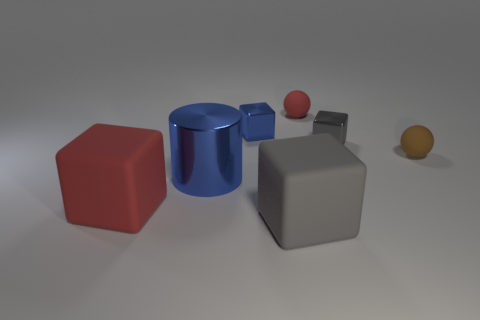Subtract all green cubes. Subtract all yellow cylinders. How many cubes are left? 4 Add 1 matte things. How many objects exist? 8 Subtract all balls. How many objects are left? 5 Add 6 small gray cubes. How many small gray cubes exist? 7 Subtract 0 yellow cylinders. How many objects are left? 7 Subtract all metallic cubes. Subtract all gray rubber cubes. How many objects are left? 4 Add 2 big blocks. How many big blocks are left? 4 